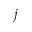Convert formula to latex. <formula><loc_0><loc_0><loc_500><loc_500>j</formula> 